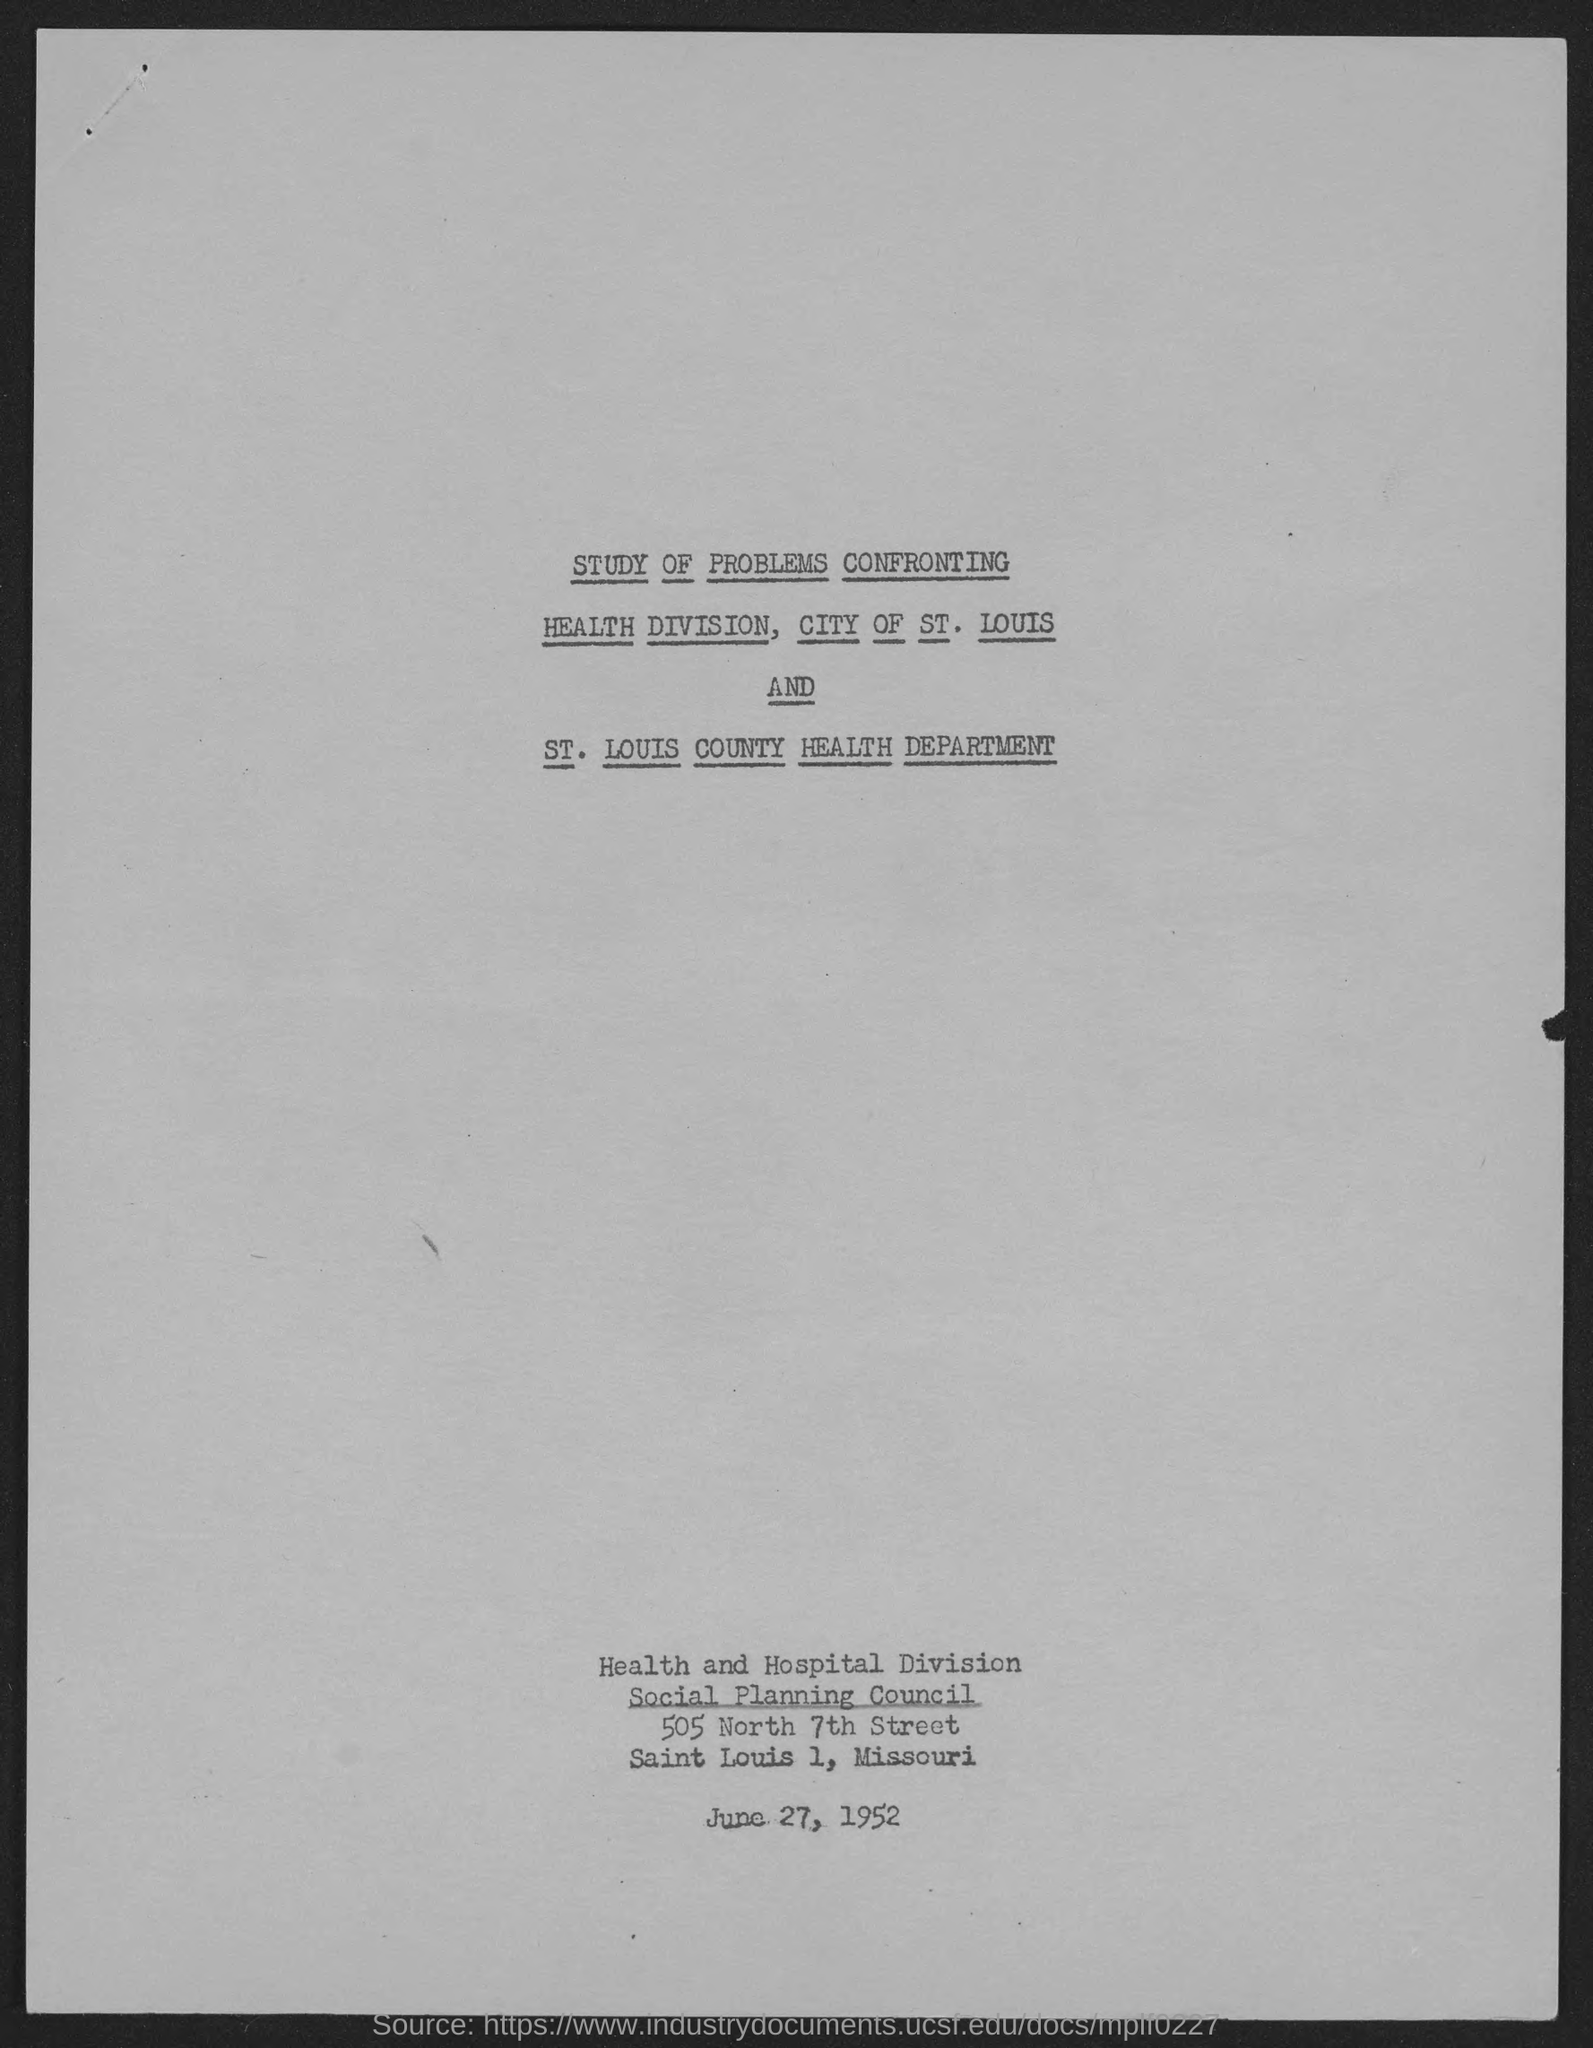When is the document dated?
Give a very brief answer. June 27, 1952. 